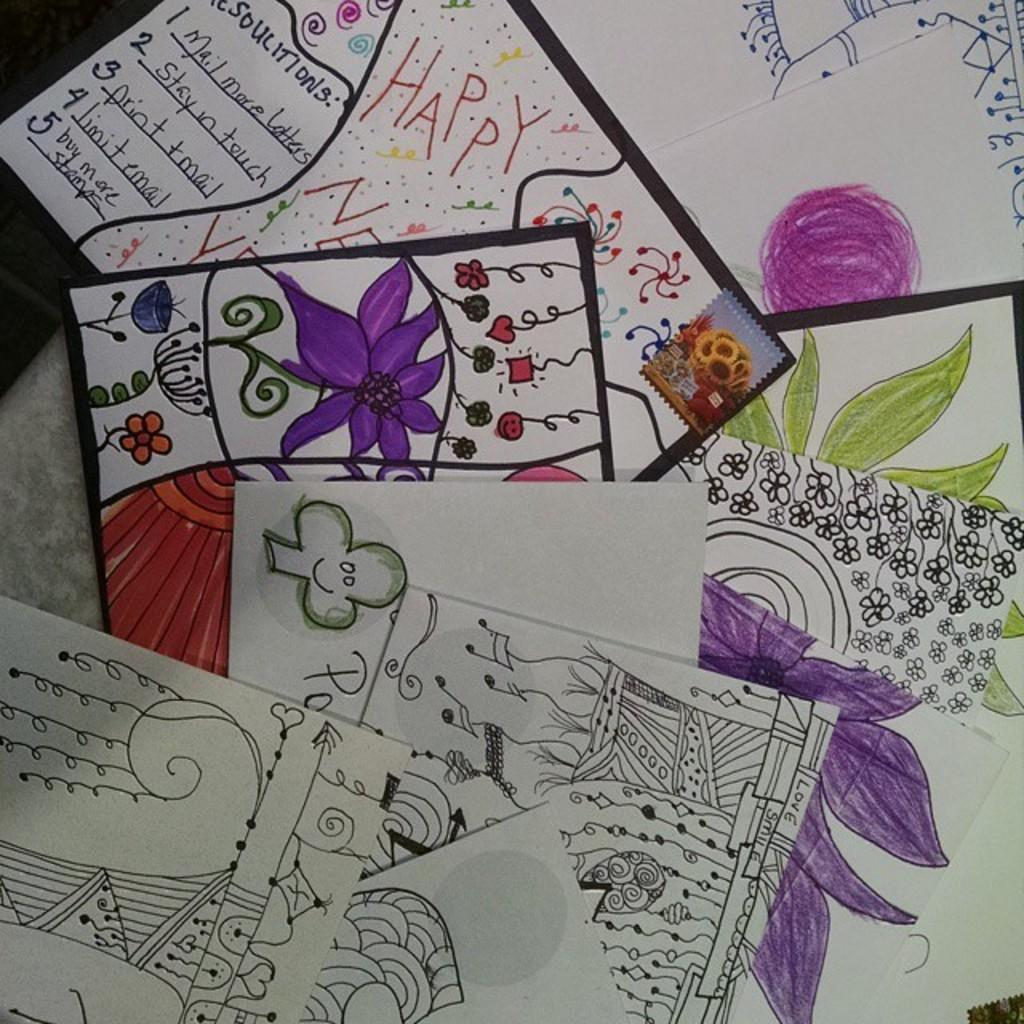What is present on the table in the image? There is a table in the image, and there are papers on the table. What can be found on the papers? The papers contain paintings and text. How many sticks are visible on the table in the image? There are no sticks visible on the table in the image. What type of card is being used to create the paintings on the papers? There is no mention of a card being used to create the paintings on the papers; the paintings are likely created using other artistic tools or techniques. 